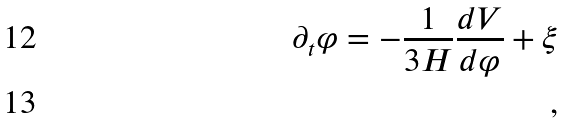Convert formula to latex. <formula><loc_0><loc_0><loc_500><loc_500>\partial _ { t } \varphi = - \frac { 1 } { 3 H } \frac { d V } { d \varphi } + \xi \\ \, ,</formula> 